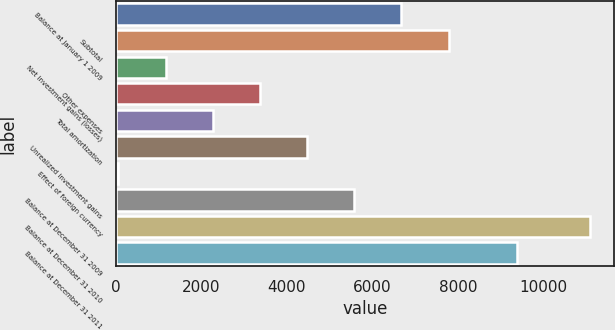Convert chart. <chart><loc_0><loc_0><loc_500><loc_500><bar_chart><fcel>Balance at January 1 2009<fcel>Subtotal<fcel>Net investment gains (losses)<fcel>Other expenses<fcel>Total amortization<fcel>Unrealized investment gains<fcel>Effect of foreign currency<fcel>Balance at December 31 2009<fcel>Balance at December 31 2010<fcel>Balance at December 31 2011<nl><fcel>6675.2<fcel>7778.4<fcel>1159.2<fcel>3365.6<fcel>2262.4<fcel>4468.8<fcel>56<fcel>5572<fcel>11088<fcel>9379<nl></chart> 